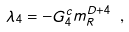<formula> <loc_0><loc_0><loc_500><loc_500>\lambda _ { 4 } = - G _ { 4 } ^ { c } m _ { R } ^ { D + 4 } \ ,</formula> 